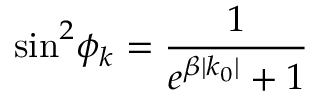<formula> <loc_0><loc_0><loc_500><loc_500>\sin ^ { 2 } \, \phi _ { k } = \frac { 1 } { e ^ { \beta | k _ { 0 } | } + 1 }</formula> 